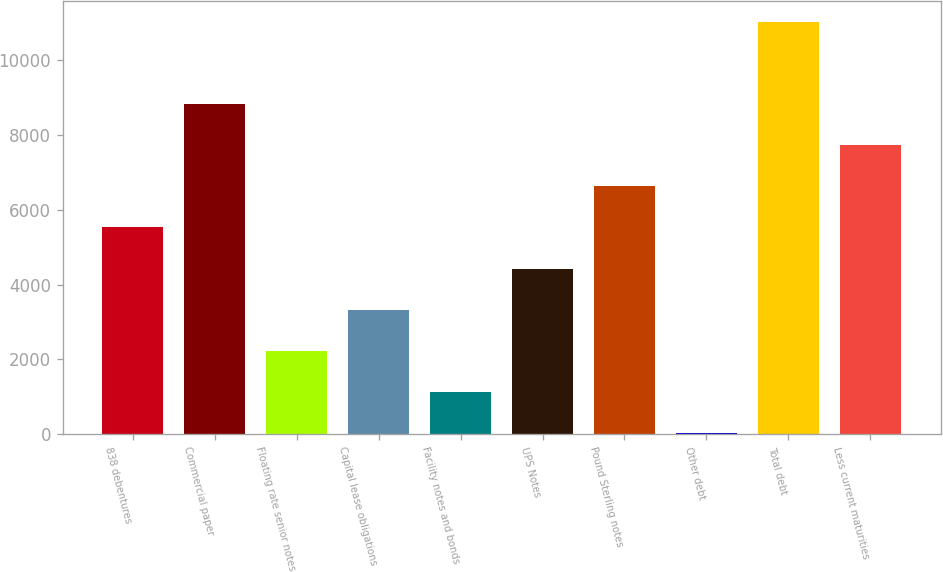<chart> <loc_0><loc_0><loc_500><loc_500><bar_chart><fcel>838 debentures<fcel>Commercial paper<fcel>Floating rate senior notes<fcel>Capital lease obligations<fcel>Facility notes and bonds<fcel>UPS Notes<fcel>Pound Sterling notes<fcel>Other debt<fcel>Total debt<fcel>Less current maturities<nl><fcel>5526<fcel>8821.2<fcel>2230.8<fcel>3329.2<fcel>1132.4<fcel>4427.6<fcel>6624.4<fcel>34<fcel>11018<fcel>7722.8<nl></chart> 